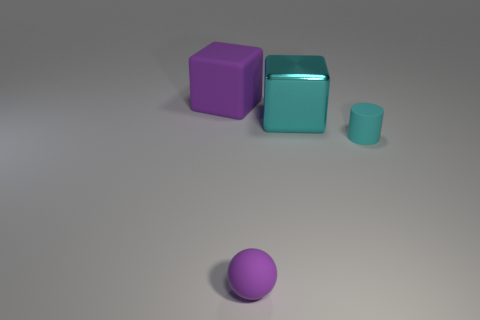There is a cylinder; does it have the same color as the cube in front of the purple cube?
Provide a short and direct response. Yes. Are there the same number of cyan cylinders right of the big rubber cube and rubber cylinders that are behind the big cyan metallic block?
Make the answer very short. No. How many big cyan shiny objects have the same shape as the large rubber object?
Provide a succinct answer. 1. Are any tiny green shiny objects visible?
Ensure brevity in your answer.  No. Does the small ball have the same material as the thing right of the large shiny block?
Provide a succinct answer. Yes. What is the material of the other block that is the same size as the purple matte block?
Provide a succinct answer. Metal. Is there another tiny purple sphere made of the same material as the purple sphere?
Provide a succinct answer. No. Is there a purple rubber sphere to the left of the big purple thing behind the cyan thing behind the tiny cyan object?
Offer a terse response. No. What shape is the object that is the same size as the cyan matte cylinder?
Ensure brevity in your answer.  Sphere. Does the cyan thing in front of the big shiny block have the same size as the thing on the left side of the tiny purple object?
Keep it short and to the point. No. 